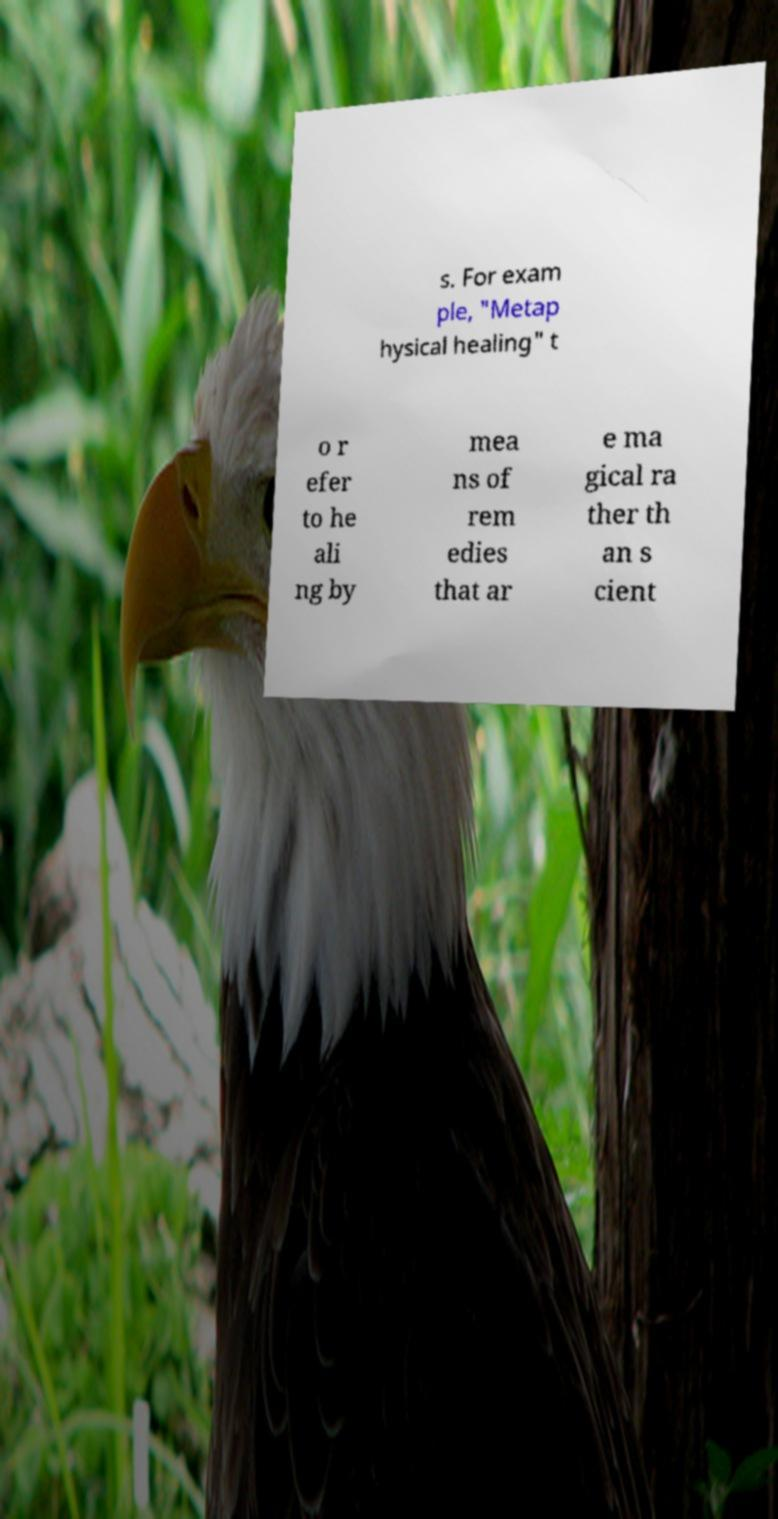Can you accurately transcribe the text from the provided image for me? s. For exam ple, "Metap hysical healing" t o r efer to he ali ng by mea ns of rem edies that ar e ma gical ra ther th an s cient 